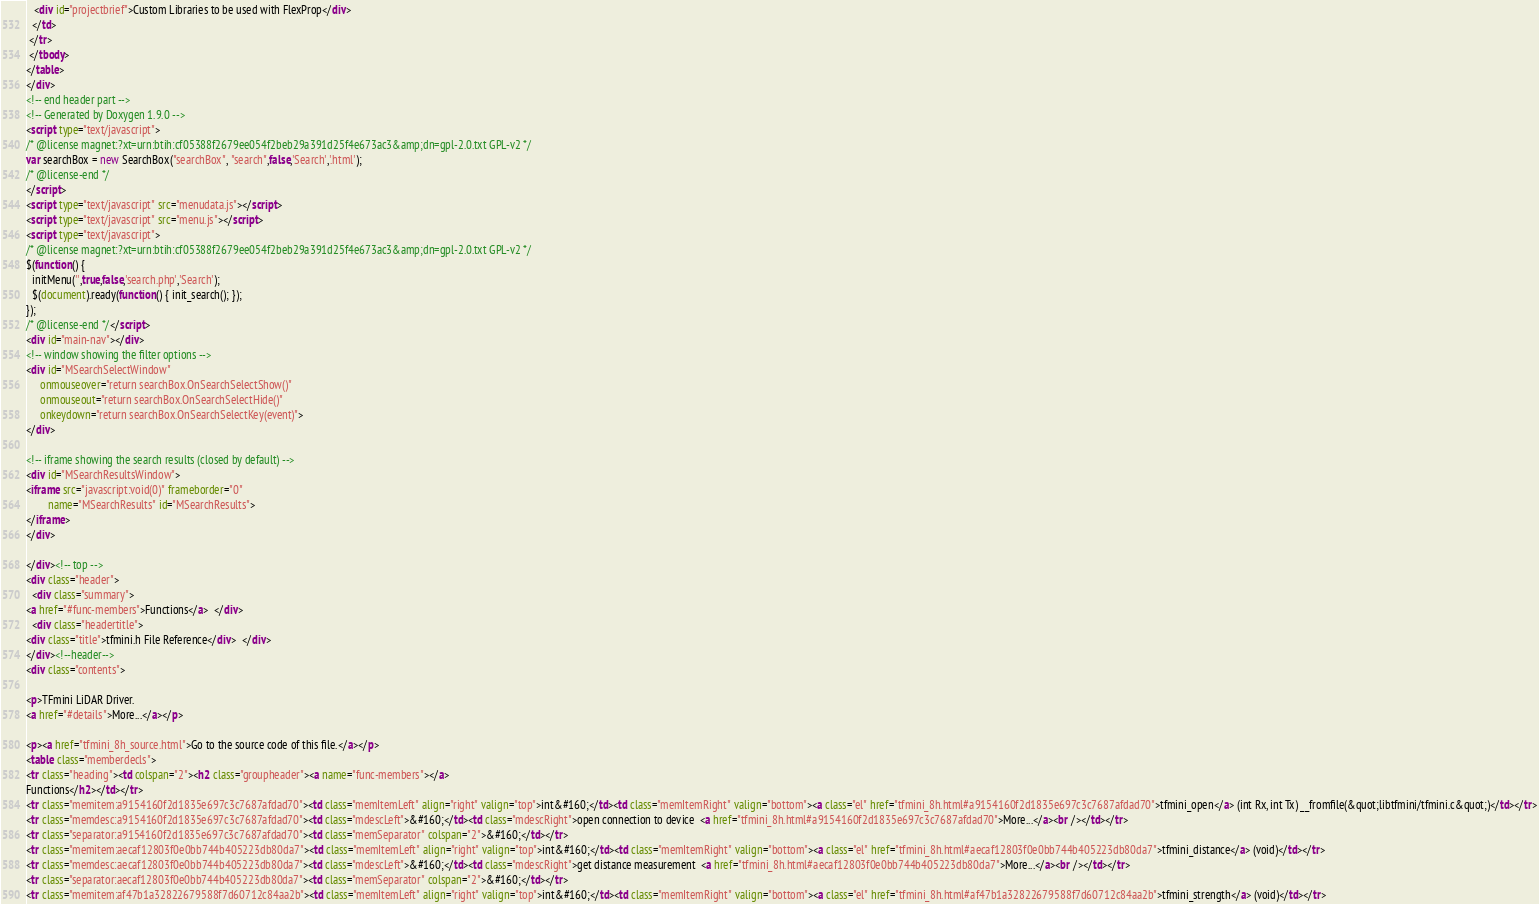Convert code to text. <code><loc_0><loc_0><loc_500><loc_500><_HTML_>   <div id="projectbrief">Custom Libraries to be used with FlexProp</div>
  </td>
 </tr>
 </tbody>
</table>
</div>
<!-- end header part -->
<!-- Generated by Doxygen 1.9.0 -->
<script type="text/javascript">
/* @license magnet:?xt=urn:btih:cf05388f2679ee054f2beb29a391d25f4e673ac3&amp;dn=gpl-2.0.txt GPL-v2 */
var searchBox = new SearchBox("searchBox", "search",false,'Search','.html');
/* @license-end */
</script>
<script type="text/javascript" src="menudata.js"></script>
<script type="text/javascript" src="menu.js"></script>
<script type="text/javascript">
/* @license magnet:?xt=urn:btih:cf05388f2679ee054f2beb29a391d25f4e673ac3&amp;dn=gpl-2.0.txt GPL-v2 */
$(function() {
  initMenu('',true,false,'search.php','Search');
  $(document).ready(function() { init_search(); });
});
/* @license-end */</script>
<div id="main-nav"></div>
<!-- window showing the filter options -->
<div id="MSearchSelectWindow"
     onmouseover="return searchBox.OnSearchSelectShow()"
     onmouseout="return searchBox.OnSearchSelectHide()"
     onkeydown="return searchBox.OnSearchSelectKey(event)">
</div>

<!-- iframe showing the search results (closed by default) -->
<div id="MSearchResultsWindow">
<iframe src="javascript:void(0)" frameborder="0" 
        name="MSearchResults" id="MSearchResults">
</iframe>
</div>

</div><!-- top -->
<div class="header">
  <div class="summary">
<a href="#func-members">Functions</a>  </div>
  <div class="headertitle">
<div class="title">tfmini.h File Reference</div>  </div>
</div><!--header-->
<div class="contents">

<p>TFmini LiDAR Driver.  
<a href="#details">More...</a></p>

<p><a href="tfmini_8h_source.html">Go to the source code of this file.</a></p>
<table class="memberdecls">
<tr class="heading"><td colspan="2"><h2 class="groupheader"><a name="func-members"></a>
Functions</h2></td></tr>
<tr class="memitem:a9154160f2d1835e697c3c7687afdad70"><td class="memItemLeft" align="right" valign="top">int&#160;</td><td class="memItemRight" valign="bottom"><a class="el" href="tfmini_8h.html#a9154160f2d1835e697c3c7687afdad70">tfmini_open</a> (int Rx, int Tx) __fromfile(&quot;libtfmini/tfmini.c&quot;)</td></tr>
<tr class="memdesc:a9154160f2d1835e697c3c7687afdad70"><td class="mdescLeft">&#160;</td><td class="mdescRight">open connection to device  <a href="tfmini_8h.html#a9154160f2d1835e697c3c7687afdad70">More...</a><br /></td></tr>
<tr class="separator:a9154160f2d1835e697c3c7687afdad70"><td class="memSeparator" colspan="2">&#160;</td></tr>
<tr class="memitem:aecaf12803f0e0bb744b405223db80da7"><td class="memItemLeft" align="right" valign="top">int&#160;</td><td class="memItemRight" valign="bottom"><a class="el" href="tfmini_8h.html#aecaf12803f0e0bb744b405223db80da7">tfmini_distance</a> (void)</td></tr>
<tr class="memdesc:aecaf12803f0e0bb744b405223db80da7"><td class="mdescLeft">&#160;</td><td class="mdescRight">get distance measurement  <a href="tfmini_8h.html#aecaf12803f0e0bb744b405223db80da7">More...</a><br /></td></tr>
<tr class="separator:aecaf12803f0e0bb744b405223db80da7"><td class="memSeparator" colspan="2">&#160;</td></tr>
<tr class="memitem:af47b1a32822679588f7d60712c84aa2b"><td class="memItemLeft" align="right" valign="top">int&#160;</td><td class="memItemRight" valign="bottom"><a class="el" href="tfmini_8h.html#af47b1a32822679588f7d60712c84aa2b">tfmini_strength</a> (void)</td></tr></code> 